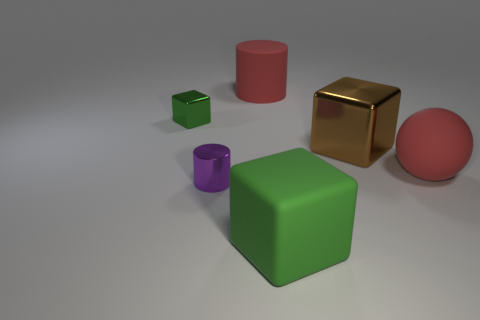What number of other things are the same material as the brown block?
Offer a very short reply. 2. There is a green cube that is the same size as the matte cylinder; what is it made of?
Your response must be concise. Rubber. How many red things are either rubber cylinders or shiny blocks?
Give a very brief answer. 1. What is the color of the shiny object that is both on the left side of the green matte block and right of the small block?
Ensure brevity in your answer.  Purple. Is the material of the ball that is in front of the small green cube the same as the tiny thing in front of the big matte ball?
Your response must be concise. No. Is the number of big rubber blocks behind the tiny green object greater than the number of large rubber balls in front of the large ball?
Your answer should be compact. No. What shape is the metallic thing that is the same size as the green shiny block?
Offer a terse response. Cylinder. What number of objects are either yellow rubber cylinders or large things behind the shiny cylinder?
Give a very brief answer. 3. Does the large ball have the same color as the rubber cylinder?
Keep it short and to the point. Yes. What number of metal cubes are to the left of the purple metal object?
Provide a succinct answer. 1. 